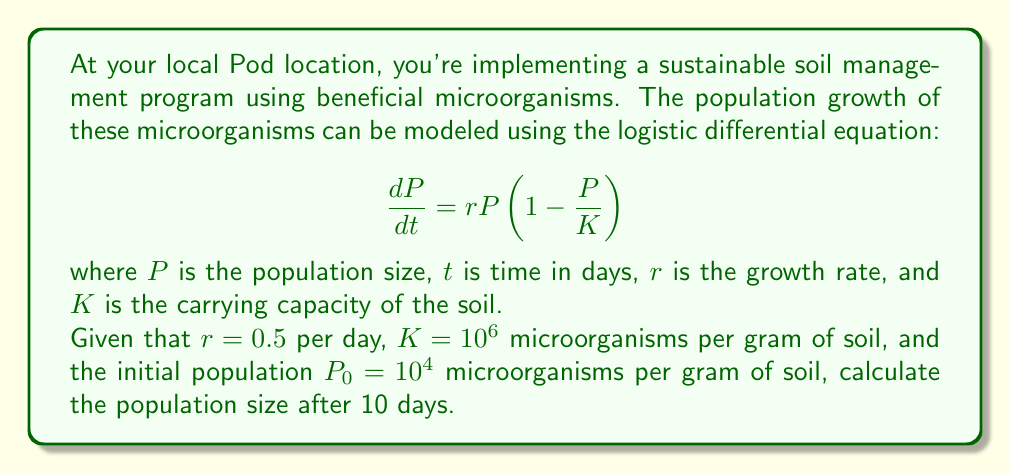Provide a solution to this math problem. To solve this problem, we need to use the solution to the logistic differential equation, which is given by:

$$P(t) = \frac{K}{1 + (\frac{K}{P_0} - 1)e^{-rt}}$$

Let's substitute the given values:
- $K = 10^6$ microorganisms per gram of soil
- $P_0 = 10^4$ microorganisms per gram of soil
- $r = 0.5$ per day
- $t = 10$ days

Step 1: Calculate $\frac{K}{P_0} - 1$
$$\frac{K}{P_0} - 1 = \frac{10^6}{10^4} - 1 = 100 - 1 = 99$$

Step 2: Calculate $e^{-rt}$
$$e^{-rt} = e^{-0.5 \times 10} = e^{-5} \approx 0.00674$$

Step 3: Substitute these values into the equation
$$P(10) = \frac{10^6}{1 + 99 \times 0.00674}$$

Step 4: Evaluate the denominator
$$1 + 99 \times 0.00674 = 1 + 0.66726 = 1.66726$$

Step 5: Calculate the final population size
$$P(10) = \frac{10^6}{1.66726} \approx 599,786$$

Therefore, after 10 days, the population of beneficial microorganisms will be approximately 599,786 per gram of soil.
Answer: 599,786 microorganisms per gram of soil 